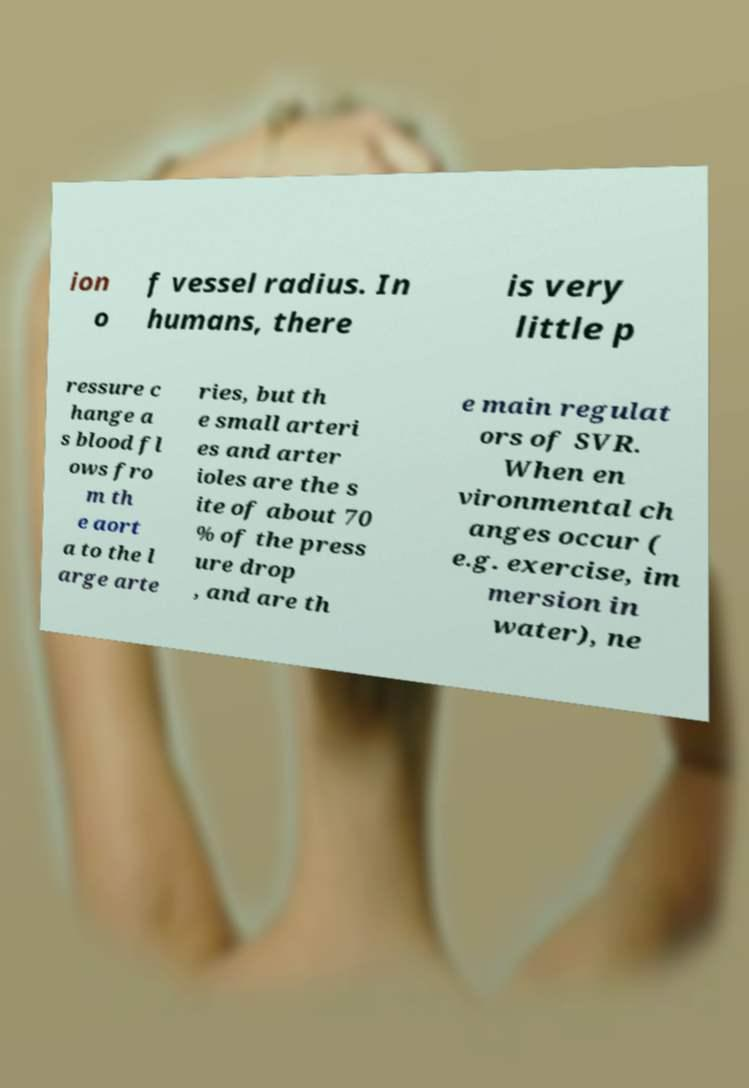Please read and relay the text visible in this image. What does it say? ion o f vessel radius. In humans, there is very little p ressure c hange a s blood fl ows fro m th e aort a to the l arge arte ries, but th e small arteri es and arter ioles are the s ite of about 70 % of the press ure drop , and are th e main regulat ors of SVR. When en vironmental ch anges occur ( e.g. exercise, im mersion in water), ne 